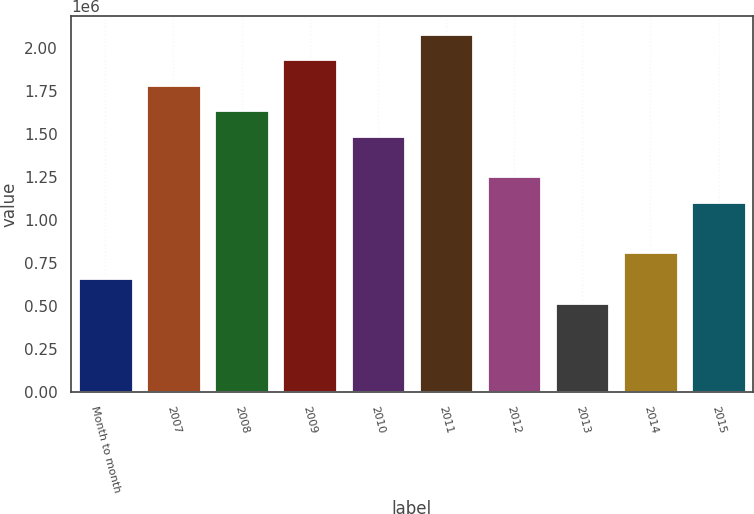Convert chart. <chart><loc_0><loc_0><loc_500><loc_500><bar_chart><fcel>Month to month<fcel>2007<fcel>2008<fcel>2009<fcel>2010<fcel>2011<fcel>2012<fcel>2013<fcel>2014<fcel>2015<nl><fcel>662900<fcel>1.7858e+06<fcel>1.6379e+06<fcel>1.9337e+06<fcel>1.49e+06<fcel>2.0816e+06<fcel>1.2545e+06<fcel>515000<fcel>810800<fcel>1.1066e+06<nl></chart> 